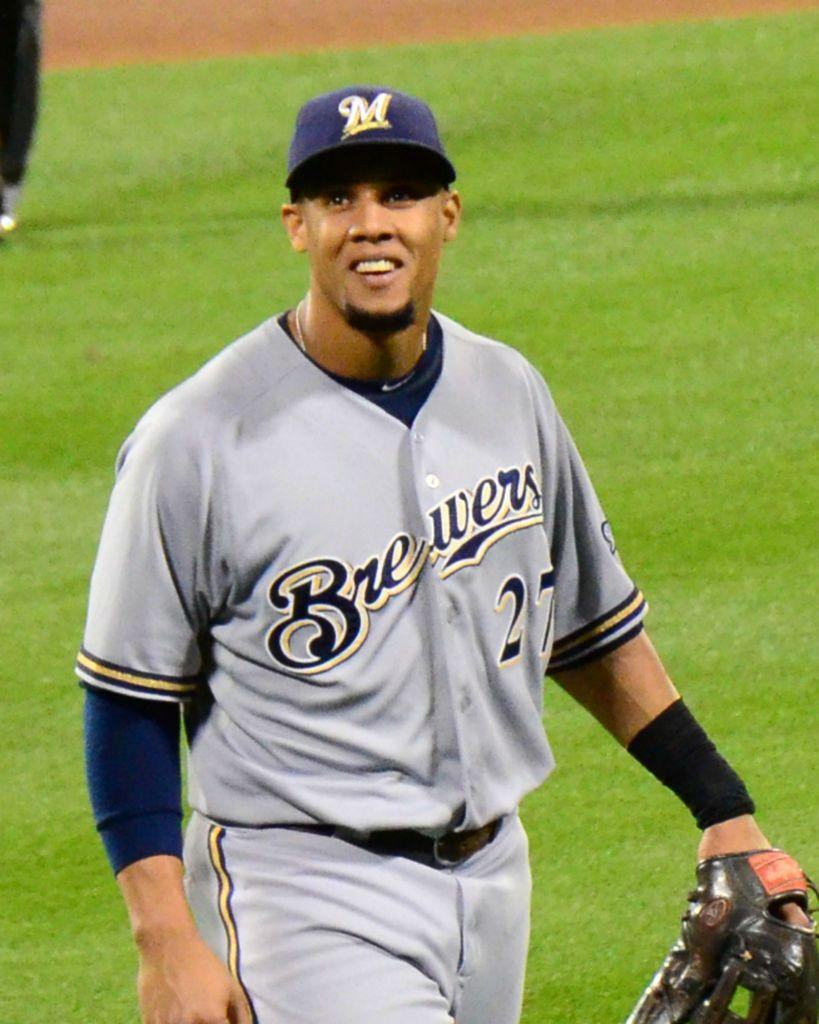<image>
Present a compact description of the photo's key features. The baseball player is wearing jersey number 27. 